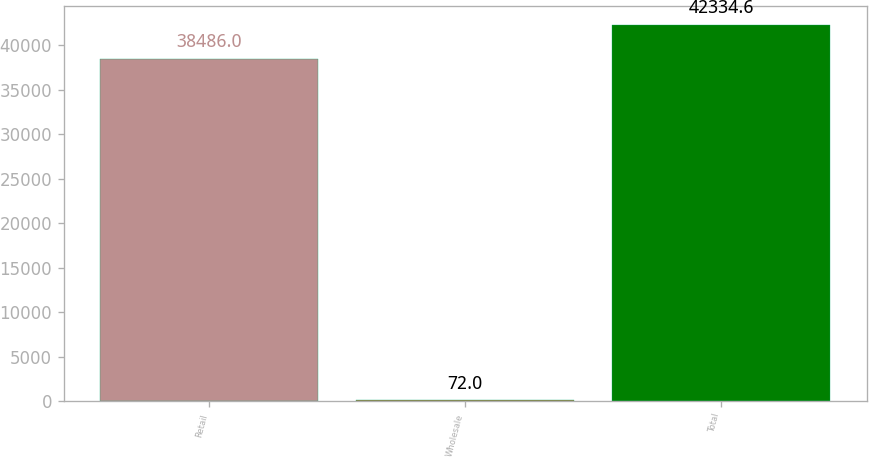Convert chart. <chart><loc_0><loc_0><loc_500><loc_500><bar_chart><fcel>Retail<fcel>Wholesale<fcel>Total<nl><fcel>38486<fcel>72<fcel>42334.6<nl></chart> 